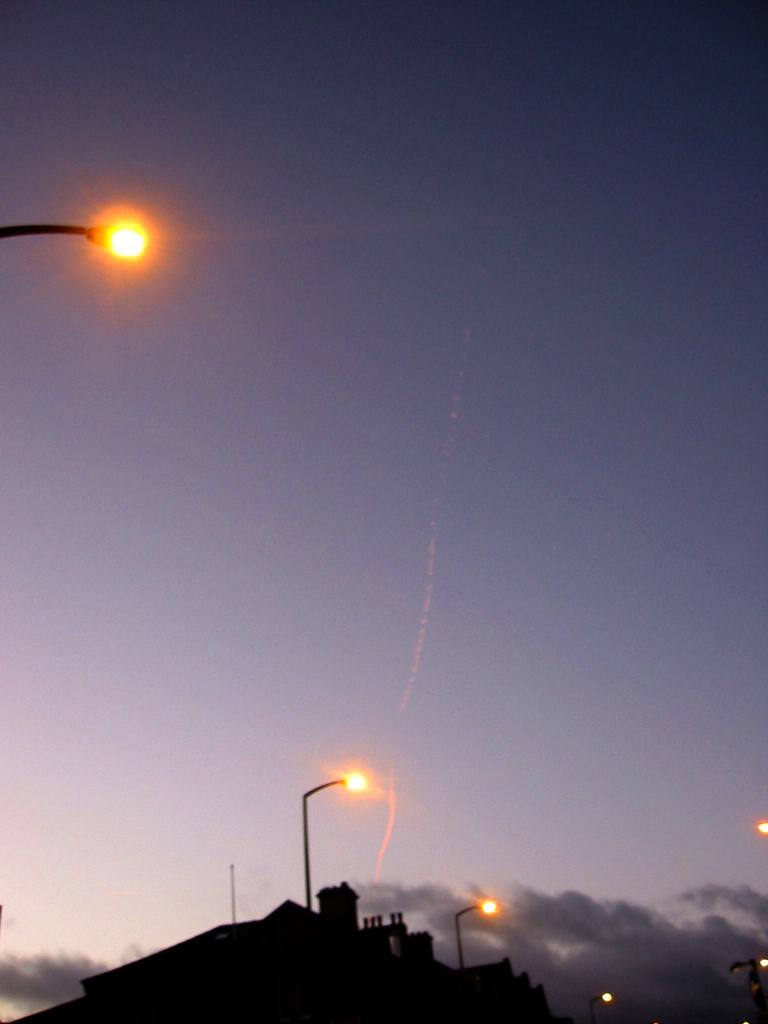What structure is located at the bottom of the image? There is a building at the bottom of the image. What type of objects are present in the image to provide illumination? There are light poles in the image. What can be seen in the background of the image? Sky is visible in the background of the image. What is the weather condition in the image? Clouds are present in the sky, indicating a partly cloudy day. How does the carpenter increase the size of the building in the image? There is no carpenter present in the image, and the size of the building cannot be increased in the image. 